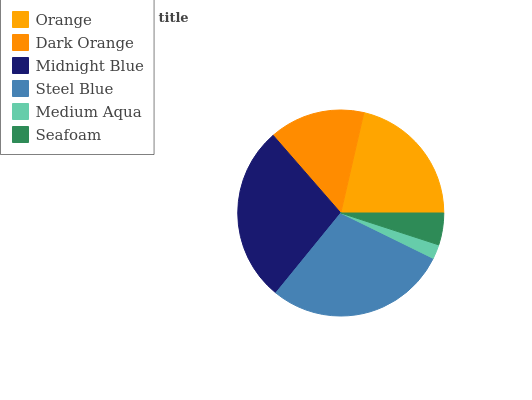Is Medium Aqua the minimum?
Answer yes or no. Yes. Is Steel Blue the maximum?
Answer yes or no. Yes. Is Dark Orange the minimum?
Answer yes or no. No. Is Dark Orange the maximum?
Answer yes or no. No. Is Orange greater than Dark Orange?
Answer yes or no. Yes. Is Dark Orange less than Orange?
Answer yes or no. Yes. Is Dark Orange greater than Orange?
Answer yes or no. No. Is Orange less than Dark Orange?
Answer yes or no. No. Is Orange the high median?
Answer yes or no. Yes. Is Dark Orange the low median?
Answer yes or no. Yes. Is Midnight Blue the high median?
Answer yes or no. No. Is Seafoam the low median?
Answer yes or no. No. 